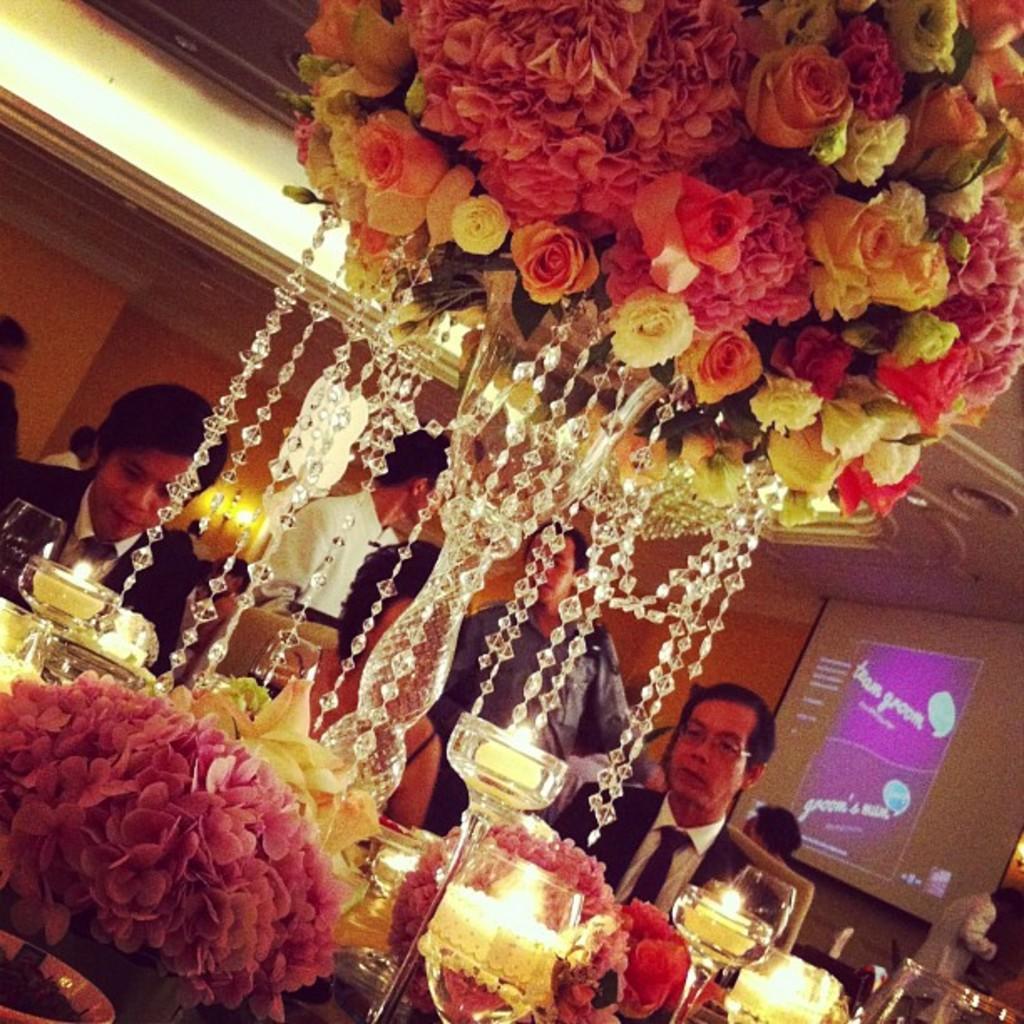How would you summarize this image in a sentence or two? In this image I can see the chandelier decorated with flowers. I can see few people are sitting in-front of the table. On the table I can see the wine glasses and flowers. In the background I can see few more people standing, screen and the wall. 